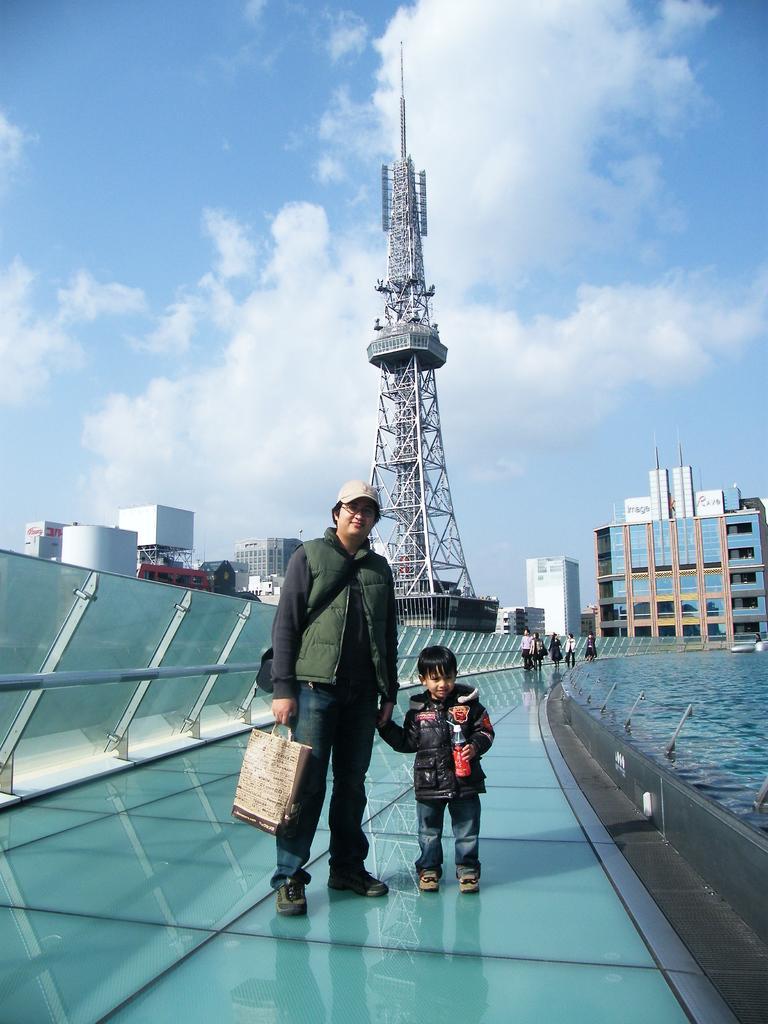In one or two sentences, can you explain what this image depicts? Above this bridge I can see people. Front a man is holding a boy hand and bag. Boy is holding a bottle. In the background of the image there is a tower, buildings, water and cloudy sky. 